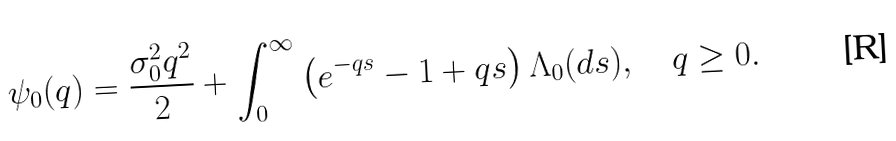<formula> <loc_0><loc_0><loc_500><loc_500>\psi _ { 0 } ( q ) = \frac { \sigma _ { 0 } ^ { 2 } q ^ { 2 } } 2 + \int _ { 0 } ^ { \infty } \left ( e ^ { - q s } - 1 + q s \right ) \Lambda _ { 0 } ( d s ) , \quad q \geq 0 .</formula> 